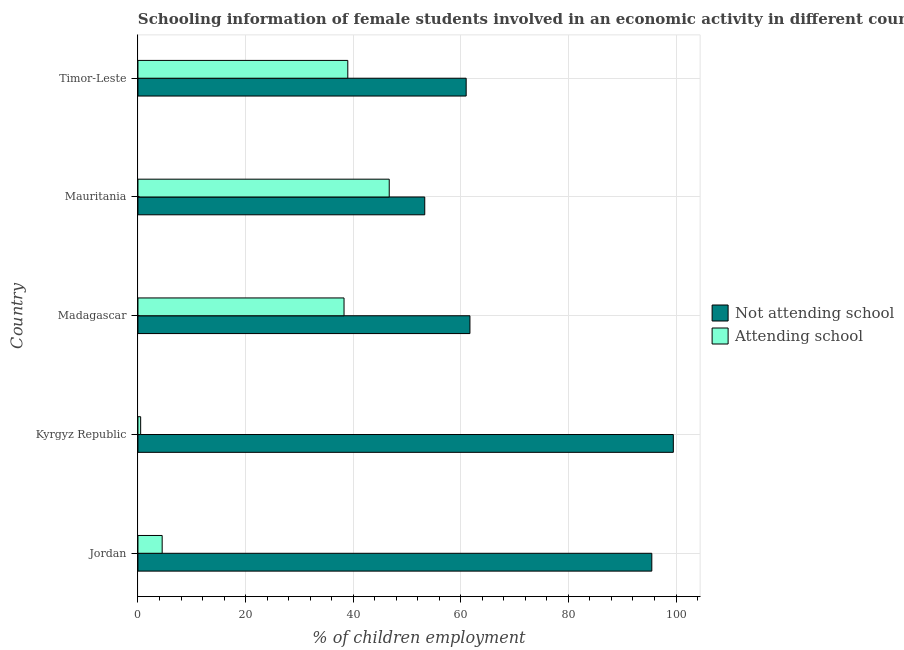How many different coloured bars are there?
Offer a terse response. 2. How many groups of bars are there?
Make the answer very short. 5. Are the number of bars per tick equal to the number of legend labels?
Offer a very short reply. Yes. What is the label of the 3rd group of bars from the top?
Your response must be concise. Madagascar. What is the percentage of employed females who are not attending school in Kyrgyz Republic?
Make the answer very short. 99.5. Across all countries, what is the maximum percentage of employed females who are attending school?
Your response must be concise. 46.7. Across all countries, what is the minimum percentage of employed females who are attending school?
Offer a terse response. 0.5. In which country was the percentage of employed females who are not attending school maximum?
Ensure brevity in your answer.  Kyrgyz Republic. In which country was the percentage of employed females who are attending school minimum?
Your answer should be compact. Kyrgyz Republic. What is the total percentage of employed females who are attending school in the graph?
Offer a terse response. 129. What is the difference between the percentage of employed females who are attending school in Timor-Leste and the percentage of employed females who are not attending school in Mauritania?
Offer a terse response. -14.3. What is the average percentage of employed females who are not attending school per country?
Give a very brief answer. 74.2. What is the difference between the percentage of employed females who are attending school and percentage of employed females who are not attending school in Jordan?
Offer a terse response. -91. What is the ratio of the percentage of employed females who are attending school in Jordan to that in Madagascar?
Your response must be concise. 0.12. What is the difference between the highest and the lowest percentage of employed females who are attending school?
Your answer should be compact. 46.2. In how many countries, is the percentage of employed females who are not attending school greater than the average percentage of employed females who are not attending school taken over all countries?
Ensure brevity in your answer.  2. What does the 2nd bar from the top in Timor-Leste represents?
Your answer should be compact. Not attending school. What does the 1st bar from the bottom in Mauritania represents?
Ensure brevity in your answer.  Not attending school. Are all the bars in the graph horizontal?
Keep it short and to the point. Yes. What is the difference between two consecutive major ticks on the X-axis?
Keep it short and to the point. 20. Are the values on the major ticks of X-axis written in scientific E-notation?
Give a very brief answer. No. Does the graph contain grids?
Give a very brief answer. Yes. How many legend labels are there?
Provide a succinct answer. 2. How are the legend labels stacked?
Your answer should be compact. Vertical. What is the title of the graph?
Provide a short and direct response. Schooling information of female students involved in an economic activity in different countries. Does "Taxes" appear as one of the legend labels in the graph?
Provide a succinct answer. No. What is the label or title of the X-axis?
Your answer should be very brief. % of children employment. What is the % of children employment of Not attending school in Jordan?
Keep it short and to the point. 95.5. What is the % of children employment of Attending school in Jordan?
Give a very brief answer. 4.5. What is the % of children employment of Not attending school in Kyrgyz Republic?
Your response must be concise. 99.5. What is the % of children employment in Not attending school in Madagascar?
Your answer should be compact. 61.7. What is the % of children employment in Attending school in Madagascar?
Ensure brevity in your answer.  38.3. What is the % of children employment of Not attending school in Mauritania?
Provide a short and direct response. 53.3. What is the % of children employment of Attending school in Mauritania?
Keep it short and to the point. 46.7. What is the % of children employment of Attending school in Timor-Leste?
Ensure brevity in your answer.  39. Across all countries, what is the maximum % of children employment of Not attending school?
Your answer should be compact. 99.5. Across all countries, what is the maximum % of children employment in Attending school?
Provide a short and direct response. 46.7. Across all countries, what is the minimum % of children employment of Not attending school?
Your response must be concise. 53.3. What is the total % of children employment in Not attending school in the graph?
Your response must be concise. 371. What is the total % of children employment of Attending school in the graph?
Provide a short and direct response. 129. What is the difference between the % of children employment of Attending school in Jordan and that in Kyrgyz Republic?
Give a very brief answer. 4. What is the difference between the % of children employment in Not attending school in Jordan and that in Madagascar?
Your answer should be compact. 33.8. What is the difference between the % of children employment of Attending school in Jordan and that in Madagascar?
Your answer should be very brief. -33.8. What is the difference between the % of children employment of Not attending school in Jordan and that in Mauritania?
Offer a very short reply. 42.2. What is the difference between the % of children employment in Attending school in Jordan and that in Mauritania?
Your answer should be very brief. -42.2. What is the difference between the % of children employment of Not attending school in Jordan and that in Timor-Leste?
Offer a very short reply. 34.5. What is the difference between the % of children employment of Attending school in Jordan and that in Timor-Leste?
Your answer should be compact. -34.5. What is the difference between the % of children employment of Not attending school in Kyrgyz Republic and that in Madagascar?
Make the answer very short. 37.8. What is the difference between the % of children employment in Attending school in Kyrgyz Republic and that in Madagascar?
Your answer should be compact. -37.8. What is the difference between the % of children employment in Not attending school in Kyrgyz Republic and that in Mauritania?
Offer a very short reply. 46.2. What is the difference between the % of children employment of Attending school in Kyrgyz Republic and that in Mauritania?
Provide a succinct answer. -46.2. What is the difference between the % of children employment in Not attending school in Kyrgyz Republic and that in Timor-Leste?
Offer a very short reply. 38.5. What is the difference between the % of children employment in Attending school in Kyrgyz Republic and that in Timor-Leste?
Offer a terse response. -38.5. What is the difference between the % of children employment of Attending school in Madagascar and that in Timor-Leste?
Provide a succinct answer. -0.7. What is the difference between the % of children employment in Not attending school in Jordan and the % of children employment in Attending school in Kyrgyz Republic?
Keep it short and to the point. 95. What is the difference between the % of children employment in Not attending school in Jordan and the % of children employment in Attending school in Madagascar?
Keep it short and to the point. 57.2. What is the difference between the % of children employment of Not attending school in Jordan and the % of children employment of Attending school in Mauritania?
Give a very brief answer. 48.8. What is the difference between the % of children employment of Not attending school in Jordan and the % of children employment of Attending school in Timor-Leste?
Keep it short and to the point. 56.5. What is the difference between the % of children employment in Not attending school in Kyrgyz Republic and the % of children employment in Attending school in Madagascar?
Your answer should be very brief. 61.2. What is the difference between the % of children employment in Not attending school in Kyrgyz Republic and the % of children employment in Attending school in Mauritania?
Provide a short and direct response. 52.8. What is the difference between the % of children employment in Not attending school in Kyrgyz Republic and the % of children employment in Attending school in Timor-Leste?
Give a very brief answer. 60.5. What is the difference between the % of children employment in Not attending school in Madagascar and the % of children employment in Attending school in Mauritania?
Give a very brief answer. 15. What is the difference between the % of children employment in Not attending school in Madagascar and the % of children employment in Attending school in Timor-Leste?
Your answer should be very brief. 22.7. What is the average % of children employment in Not attending school per country?
Provide a short and direct response. 74.2. What is the average % of children employment of Attending school per country?
Ensure brevity in your answer.  25.8. What is the difference between the % of children employment of Not attending school and % of children employment of Attending school in Jordan?
Your answer should be compact. 91. What is the difference between the % of children employment of Not attending school and % of children employment of Attending school in Kyrgyz Republic?
Offer a terse response. 99. What is the difference between the % of children employment of Not attending school and % of children employment of Attending school in Madagascar?
Offer a very short reply. 23.4. What is the ratio of the % of children employment in Not attending school in Jordan to that in Kyrgyz Republic?
Ensure brevity in your answer.  0.96. What is the ratio of the % of children employment of Attending school in Jordan to that in Kyrgyz Republic?
Your answer should be very brief. 9. What is the ratio of the % of children employment of Not attending school in Jordan to that in Madagascar?
Make the answer very short. 1.55. What is the ratio of the % of children employment of Attending school in Jordan to that in Madagascar?
Ensure brevity in your answer.  0.12. What is the ratio of the % of children employment of Not attending school in Jordan to that in Mauritania?
Your response must be concise. 1.79. What is the ratio of the % of children employment of Attending school in Jordan to that in Mauritania?
Make the answer very short. 0.1. What is the ratio of the % of children employment in Not attending school in Jordan to that in Timor-Leste?
Provide a succinct answer. 1.57. What is the ratio of the % of children employment in Attending school in Jordan to that in Timor-Leste?
Offer a terse response. 0.12. What is the ratio of the % of children employment of Not attending school in Kyrgyz Republic to that in Madagascar?
Your answer should be very brief. 1.61. What is the ratio of the % of children employment of Attending school in Kyrgyz Republic to that in Madagascar?
Your answer should be compact. 0.01. What is the ratio of the % of children employment in Not attending school in Kyrgyz Republic to that in Mauritania?
Provide a succinct answer. 1.87. What is the ratio of the % of children employment in Attending school in Kyrgyz Republic to that in Mauritania?
Provide a succinct answer. 0.01. What is the ratio of the % of children employment of Not attending school in Kyrgyz Republic to that in Timor-Leste?
Give a very brief answer. 1.63. What is the ratio of the % of children employment of Attending school in Kyrgyz Republic to that in Timor-Leste?
Give a very brief answer. 0.01. What is the ratio of the % of children employment of Not attending school in Madagascar to that in Mauritania?
Provide a succinct answer. 1.16. What is the ratio of the % of children employment of Attending school in Madagascar to that in Mauritania?
Ensure brevity in your answer.  0.82. What is the ratio of the % of children employment in Not attending school in Madagascar to that in Timor-Leste?
Your response must be concise. 1.01. What is the ratio of the % of children employment of Attending school in Madagascar to that in Timor-Leste?
Your answer should be compact. 0.98. What is the ratio of the % of children employment of Not attending school in Mauritania to that in Timor-Leste?
Give a very brief answer. 0.87. What is the ratio of the % of children employment in Attending school in Mauritania to that in Timor-Leste?
Provide a succinct answer. 1.2. What is the difference between the highest and the second highest % of children employment of Not attending school?
Ensure brevity in your answer.  4. What is the difference between the highest and the lowest % of children employment of Not attending school?
Provide a short and direct response. 46.2. What is the difference between the highest and the lowest % of children employment of Attending school?
Your answer should be very brief. 46.2. 